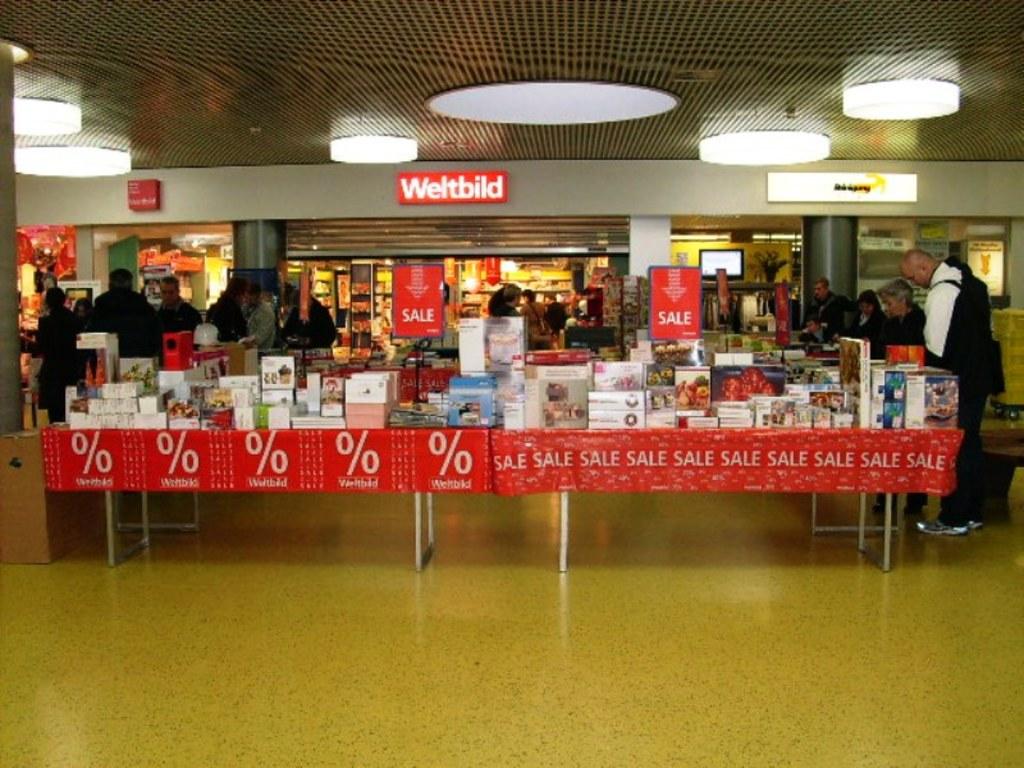Is this a big sale for wwltbild?
Your answer should be very brief. No. What is on the red banner around the table on the right?
Give a very brief answer. Sale. 